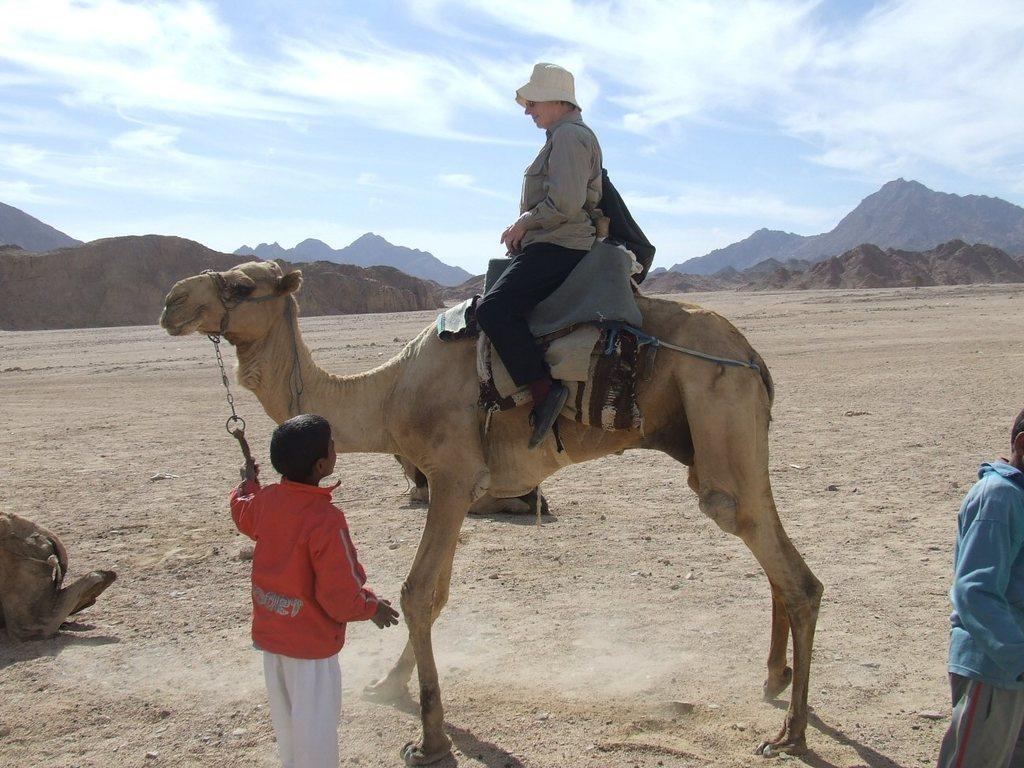How would you summarize this image in a sentence or two? This is an outside view. Here I can see a person is sitting on the camel. At the back I can see two more camels are sitting on the ground and two persons are standing. In the background there are some hills. At the top I can see the sky and clouds. 